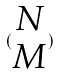<formula> <loc_0><loc_0><loc_500><loc_500>( \begin{matrix} N \\ M \end{matrix} )</formula> 